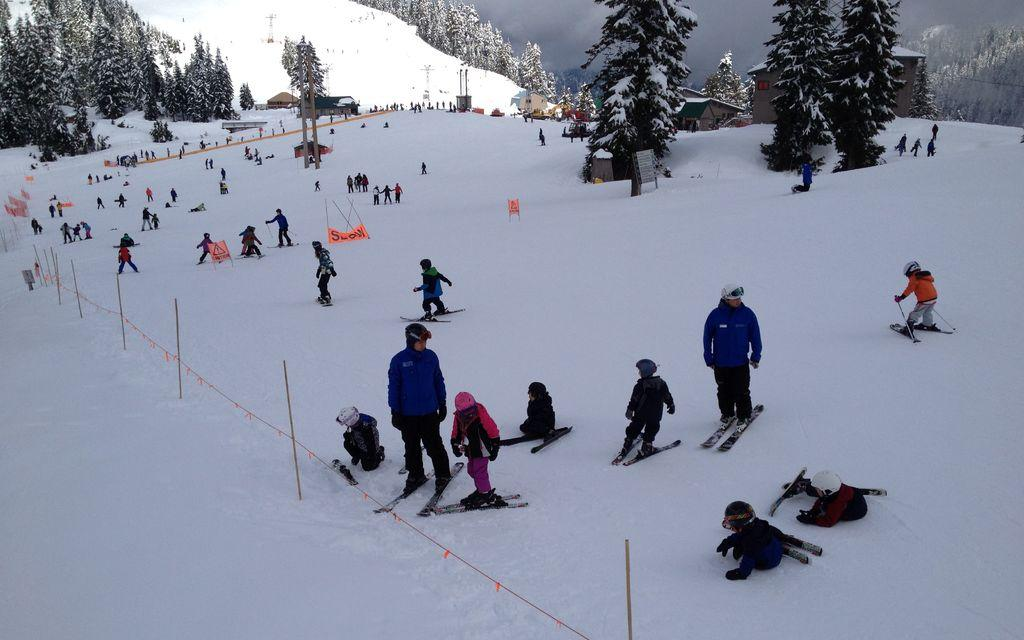What activity are the people in the image engaged in? The people in the image are skating on the surface of the snow. What can be seen in the background of the image? There are houses and trees in the background of the image. Where is the kitty playing with a pear in the image? There is no kitty or pear present in the image; it features people skating on the snow with houses and trees in the background. 